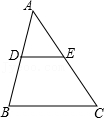Please explain why D is the midpoint of AB and how this affects the properties of triangle ADE related to triangle ABC. D being the midpoint of AB means that AD and DB are equal in length, each being half of AB. This positioning of D creates congruence between segments within the triangles and establishes that triangle ADE is similar to triangle ABC, but at a smaller scale. The sides of triangle ADE are exactly half the lengths of the respective sides of ABC, preserving the shape but scaling down the size symmetrically. This property is integral to understanding geometric similarity and scaling effects in triangles. 